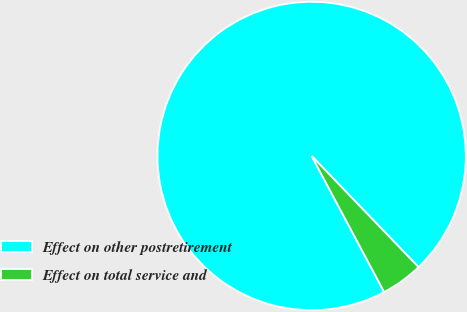<chart> <loc_0><loc_0><loc_500><loc_500><pie_chart><fcel>Effect on other postretirement<fcel>Effect on total service and<nl><fcel>95.61%<fcel>4.39%<nl></chart> 